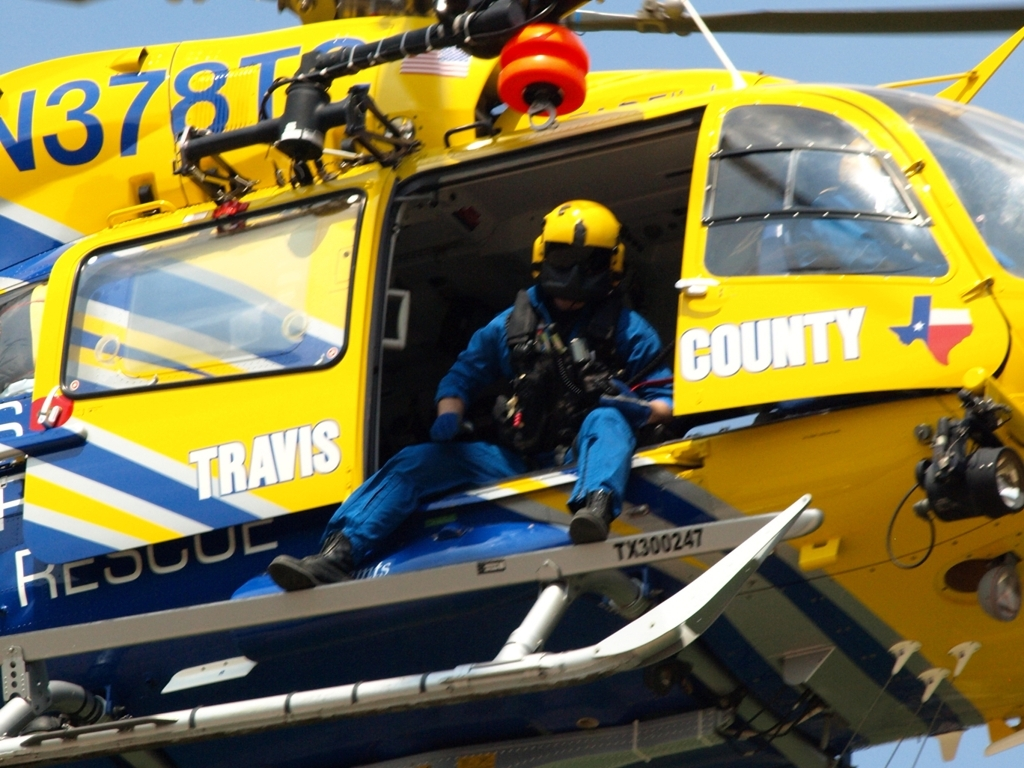What does the evaluation result show?
A. The image has high clarity, rich details, sharp edges, and vibrant colors.
B. The image has low clarity, few details, blurry edges, and dull colors.
C. The image has average clarity, moderate details, soft edges, and muted colors.
Answer with the option's letter from the given choices directly.
 A. 